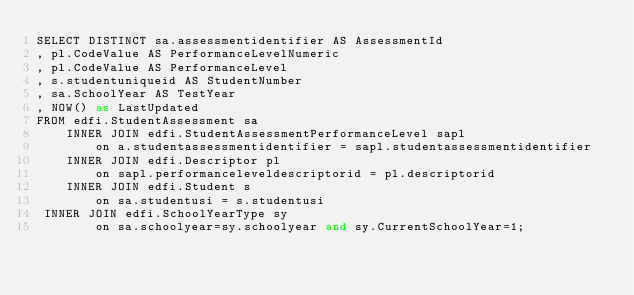<code> <loc_0><loc_0><loc_500><loc_500><_SQL_>SELECT DISTINCT sa.assessmentidentifier AS AssessmentId
, pl.CodeValue AS PerformanceLevelNumeric
, pl.CodeValue AS PerformanceLevel
, s.studentuniqueid AS StudentNumber
, sa.SchoolYear AS TestYear
, NOW() as LastUpdated
FROM edfi.StudentAssessment sa
    INNER JOIN edfi.StudentAssessmentPerformanceLevel sapl 
        on a.studentassessmentidentifier = sapl.studentassessmentidentifier
    INNER JOIN edfi.Descriptor pl
        on sapl.performanceleveldescriptorid = pl.descriptorid
    INNER JOIN edfi.Student s 
        on sa.studentusi = s.studentusi
 INNER JOIN edfi.SchoolYearType sy
        on sa.schoolyear=sy.schoolyear and sy.CurrentSchoolYear=1;</code> 